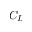<formula> <loc_0><loc_0><loc_500><loc_500>C _ { L }</formula> 